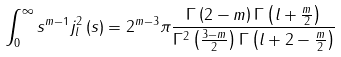Convert formula to latex. <formula><loc_0><loc_0><loc_500><loc_500>\int _ { 0 } ^ { \infty } s ^ { m - 1 } j _ { l } ^ { 2 } \left ( s \right ) = 2 ^ { m - 3 } \pi \frac { \Gamma \left ( 2 - m \right ) \Gamma \left ( l + \frac { m } { 2 } \right ) } { \Gamma ^ { 2 } \left ( \frac { 3 - m } { 2 } \right ) \Gamma \left ( l + 2 - \frac { m } { 2 } \right ) }</formula> 